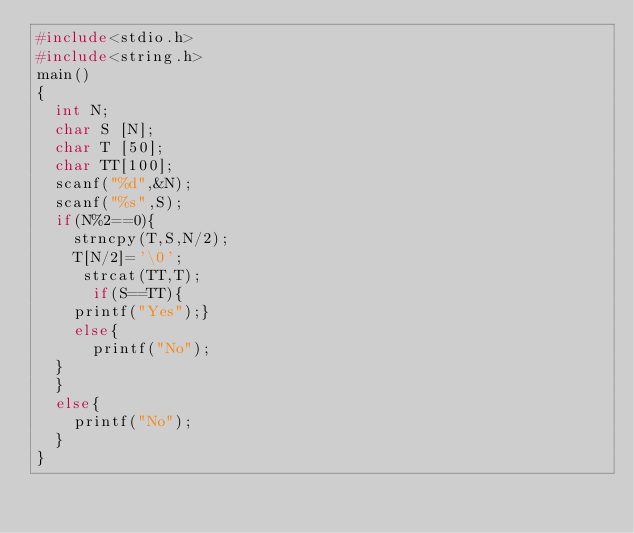Convert code to text. <code><loc_0><loc_0><loc_500><loc_500><_C_>#include<stdio.h>
#include<string.h>
main()
{
  int N;
  char S [N];
  char T [50];
  char TT[100];
  scanf("%d",&N);
  scanf("%s",S);
  if(N%2==0){
    strncpy(T,S,N/2);
    T[N/2]='\0';
     strcat(TT,T);
      if(S==TT){
    printf("Yes");}
    else{
      printf("No");
  }
  }
  else{
    printf("No");
  }
}
    
  
</code> 